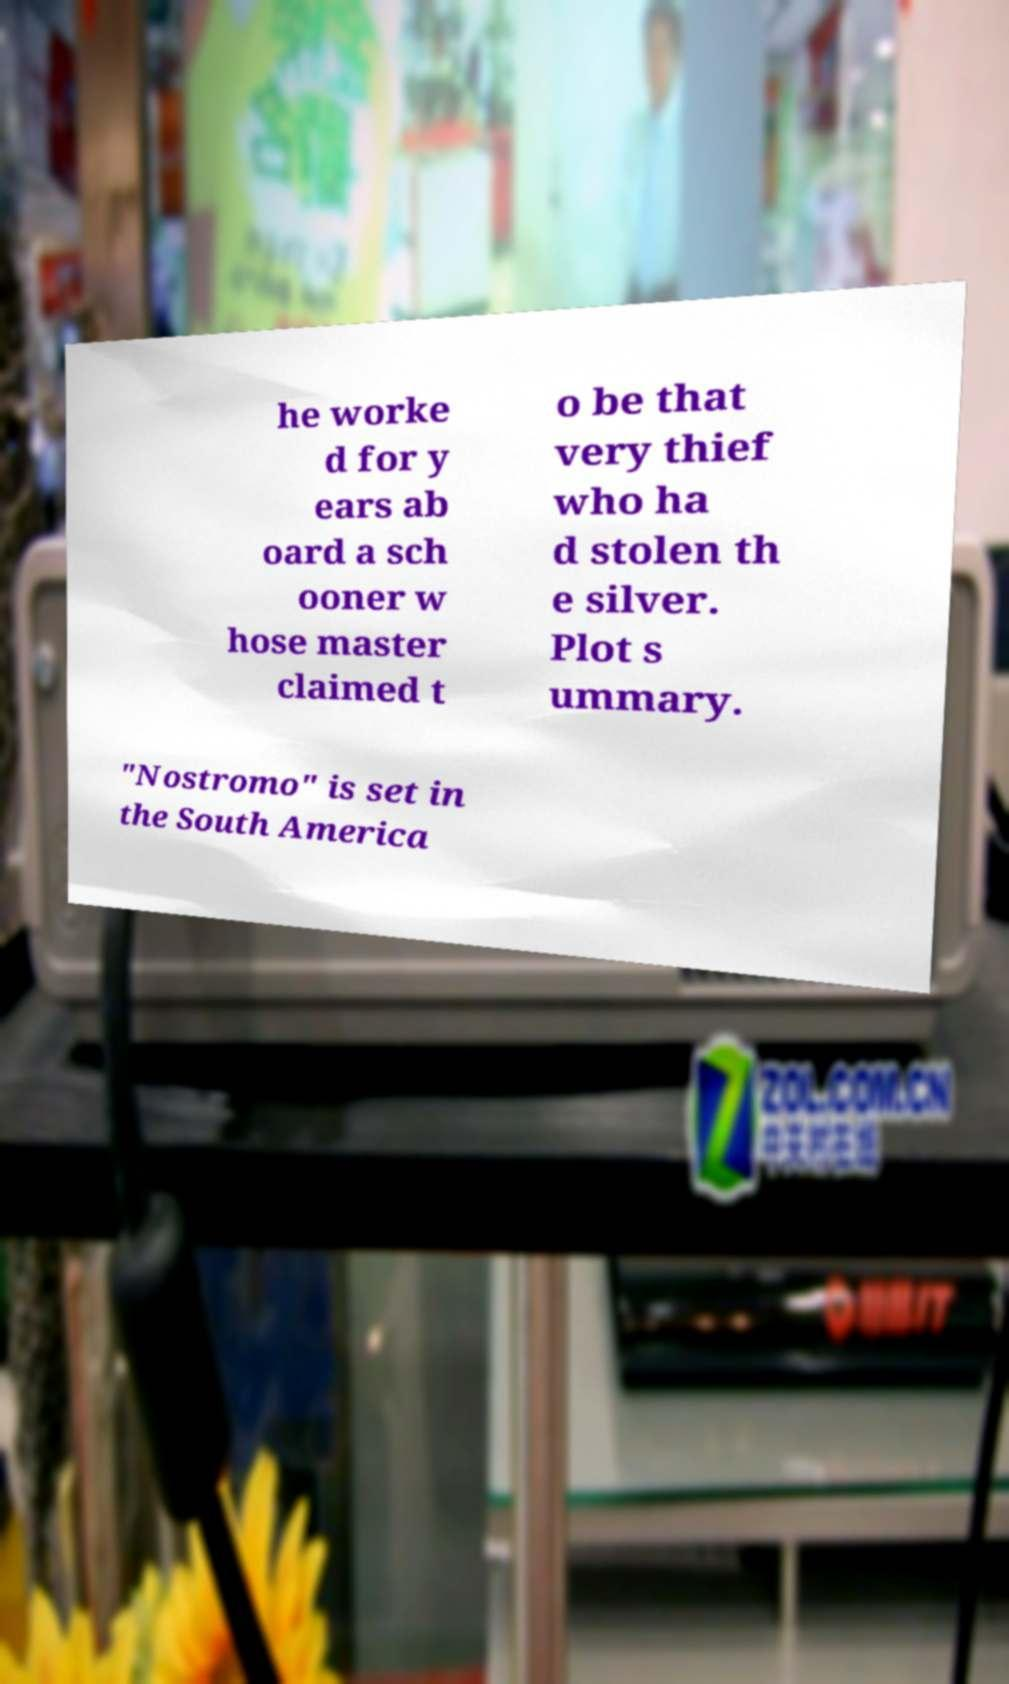For documentation purposes, I need the text within this image transcribed. Could you provide that? he worke d for y ears ab oard a sch ooner w hose master claimed t o be that very thief who ha d stolen th e silver. Plot s ummary. "Nostromo" is set in the South America 